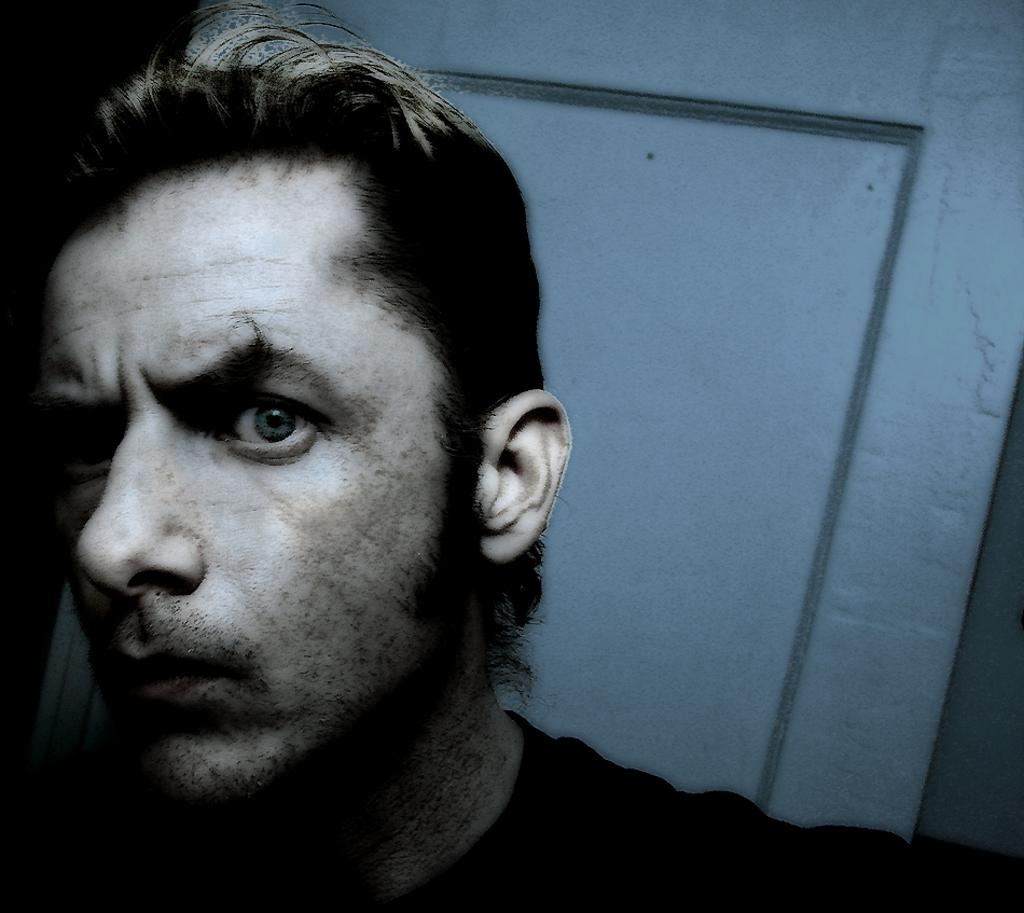What is located in the front of the image? There is a person in the front of the image. What can be seen in the background of the image? There is a door in the background of the image. How many cows are visible in the image? There are no cows present in the image. What type of notebook is the person holding in the image? There is no notebook visible in the image. 